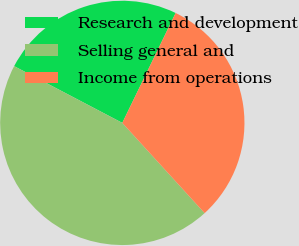Convert chart to OTSL. <chart><loc_0><loc_0><loc_500><loc_500><pie_chart><fcel>Research and development<fcel>Selling general and<fcel>Income from operations<nl><fcel>24.5%<fcel>44.46%<fcel>31.04%<nl></chart> 